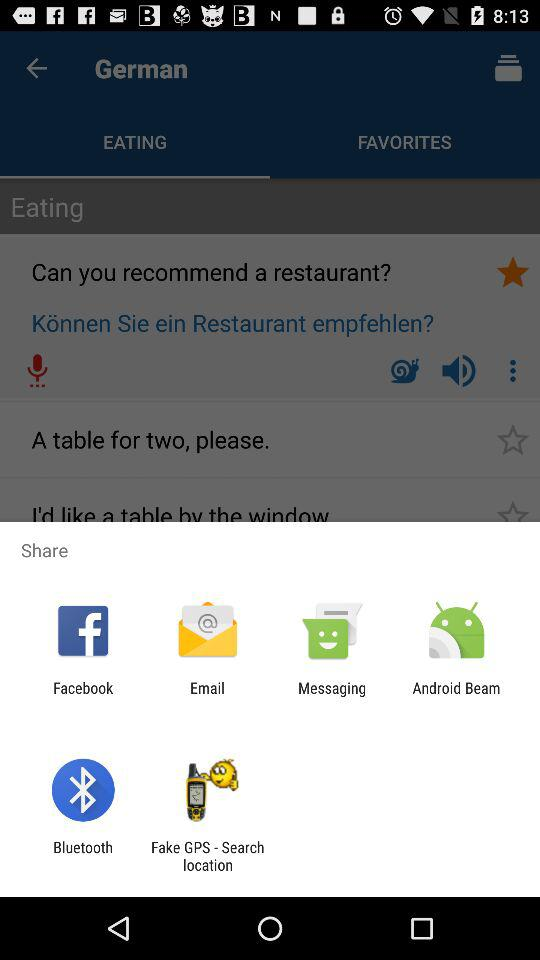How many people have recommended the restaurant?
When the provided information is insufficient, respond with <no answer>. <no answer> 